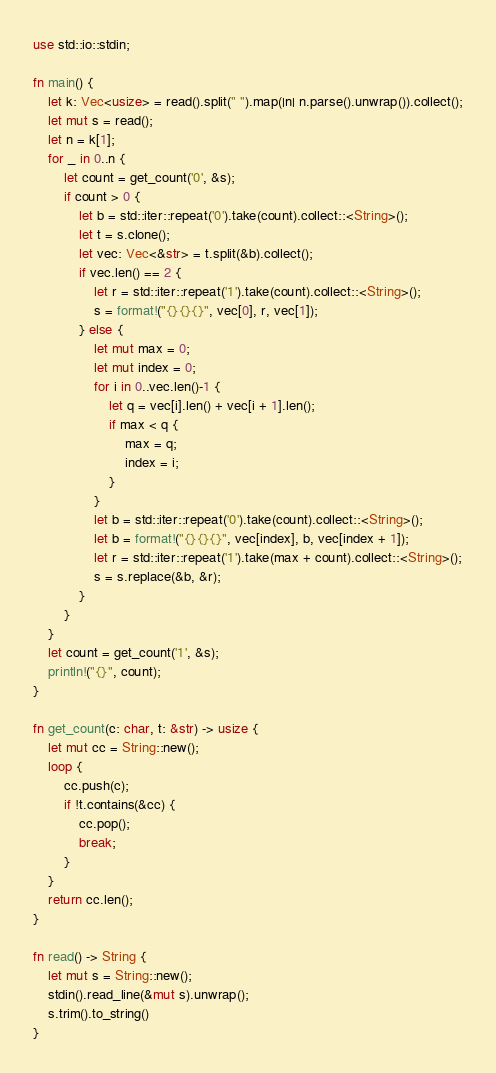<code> <loc_0><loc_0><loc_500><loc_500><_Rust_>use std::io::stdin;

fn main() {
    let k: Vec<usize> = read().split(" ").map(|n| n.parse().unwrap()).collect();
    let mut s = read();
    let n = k[1];
    for _ in 0..n {
        let count = get_count('0', &s);
        if count > 0 {
            let b = std::iter::repeat('0').take(count).collect::<String>();
            let t = s.clone();
            let vec: Vec<&str> = t.split(&b).collect();
            if vec.len() == 2 {
                let r = std::iter::repeat('1').take(count).collect::<String>();
                s = format!("{}{}{}", vec[0], r, vec[1]);
            } else {
                let mut max = 0;
                let mut index = 0;
                for i in 0..vec.len()-1 {
                    let q = vec[i].len() + vec[i + 1].len();
                    if max < q {
                        max = q;
                        index = i;
                    }
                }
                let b = std::iter::repeat('0').take(count).collect::<String>();
                let b = format!("{}{}{}", vec[index], b, vec[index + 1]);
                let r = std::iter::repeat('1').take(max + count).collect::<String>();
                s = s.replace(&b, &r);
            }
        }
    }
    let count = get_count('1', &s);
    println!("{}", count);
}

fn get_count(c: char, t: &str) -> usize {
    let mut cc = String::new();
    loop {
        cc.push(c);
        if !t.contains(&cc) {
            cc.pop();
            break;
        }
    }
    return cc.len();
}

fn read() -> String {
    let mut s = String::new();
    stdin().read_line(&mut s).unwrap();
    s.trim().to_string()
}</code> 